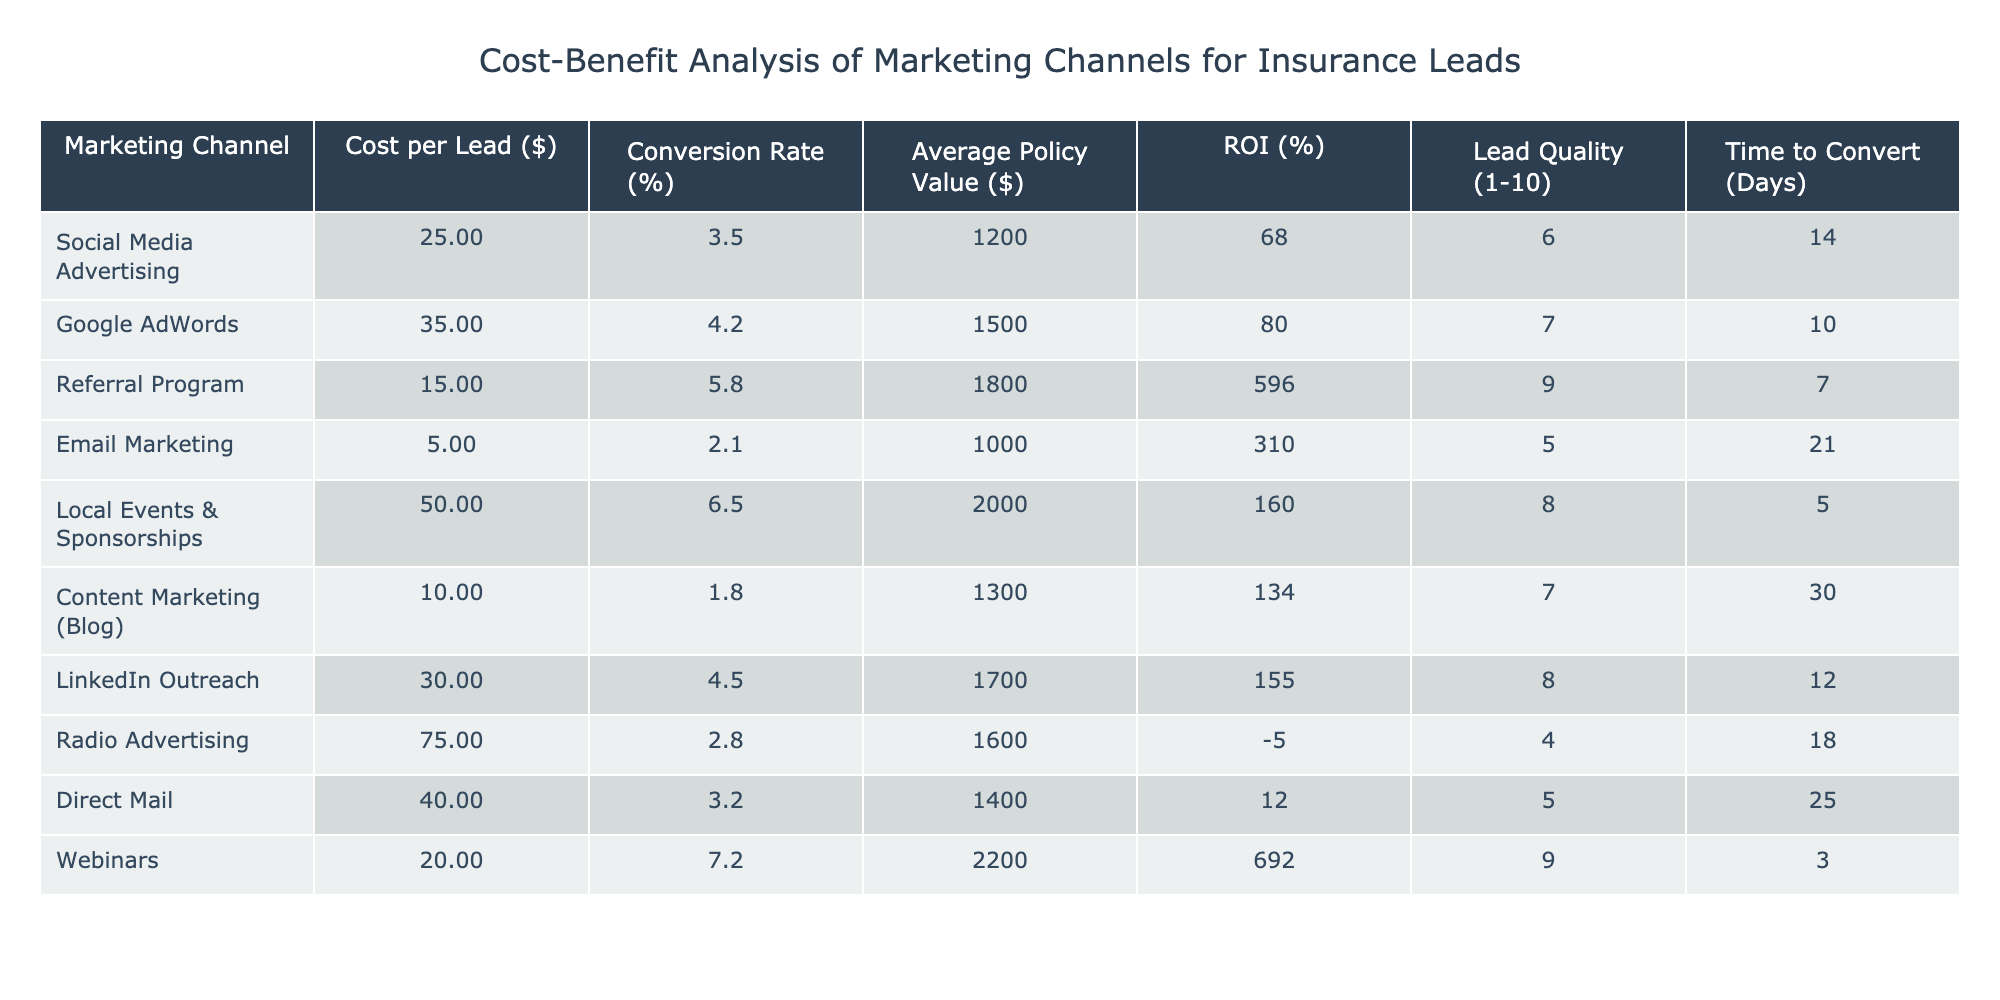What is the highest ROI among the marketing channels? By examining the ROI column, the highest value is 692% associated with Webinars.
Answer: 692% Which marketing channel has the lowest Conversion Rate? Looking through the Conversion Rate column, Radio Advertising has the lowest value at 2.8%.
Answer: 2.8% What is the average cost per lead for Social Media Advertising and Email Marketing combined? The cost per lead for Social Media Advertising is $25, and for Email Marketing, it is $5. The average is calculated as (25 + 5) / 2 = 15.
Answer: 15 Is the Lead Quality for Google AdWords higher than for Direct Mail? The Lead Quality for Google AdWords is 7 while Direct Mail's Lead Quality is 5. Since 7 is greater than 5, the answer is yes.
Answer: Yes What is the total Policy Value for the top three marketing channels by Conversion Rate? The top three channels by Conversion Rate are Webinars (2200), Local Events & Sponsorships (2000), and Referral Program (1800). Adding these gives 2200 + 2000 + 1800 = 6000.
Answer: 6000 Which marketing channel takes the least time to convert leads? By reviewing the Time to Convert column, Webinars take the least time at 3 days.
Answer: 3 days What is the difference in lead quality between the best and worst performing channels? The best performing channel for lead quality is Referral Program with a score of 9, and the worst is Radio Advertising with a score of 4. The difference is 9 - 4 = 5.
Answer: 5 Which marketing channel offers the best return on investment relative to its cost per lead? Analyzing the ROI and Cost per Lead, Referral Program offers a high ROI of 596% with a low cost per lead of $15, making it the best performer.
Answer: Referral Program How many marketing channels have an ROI greater than 100%? The channels with an ROI greater than 100% are Referral Program (596), Webinars (692), and Google AdWords (80). This totals to three channels.
Answer: 3 What is the highest Average Policy Value among the marketing channels? The Average Policy Value column shows that Local Events & Sponsorships have the highest policy value at $2000.
Answer: 2000 